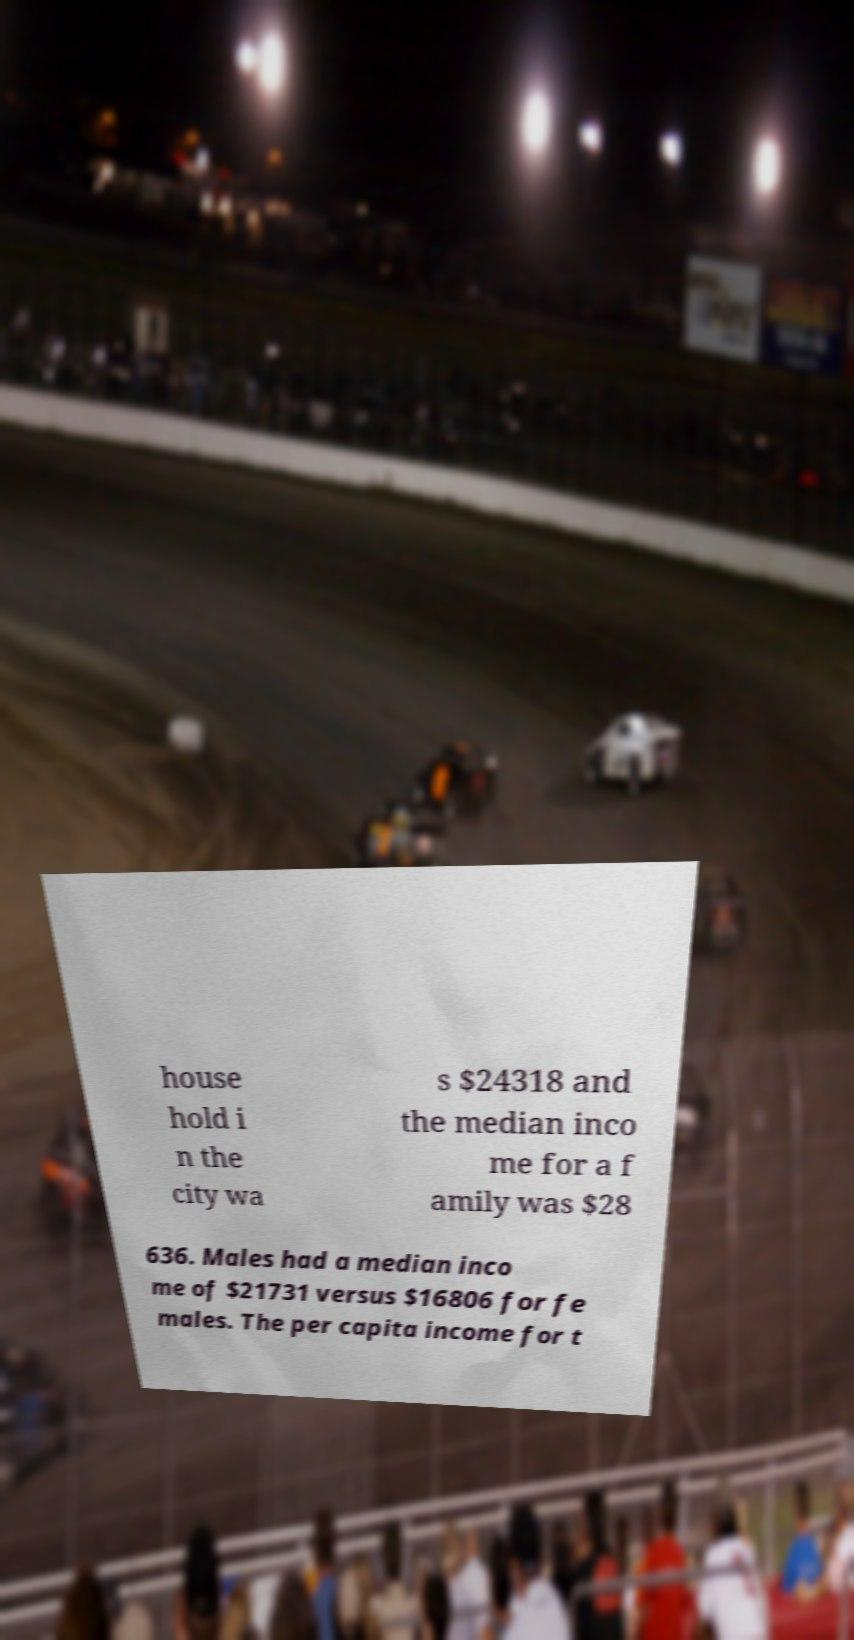There's text embedded in this image that I need extracted. Can you transcribe it verbatim? house hold i n the city wa s $24318 and the median inco me for a f amily was $28 636. Males had a median inco me of $21731 versus $16806 for fe males. The per capita income for t 